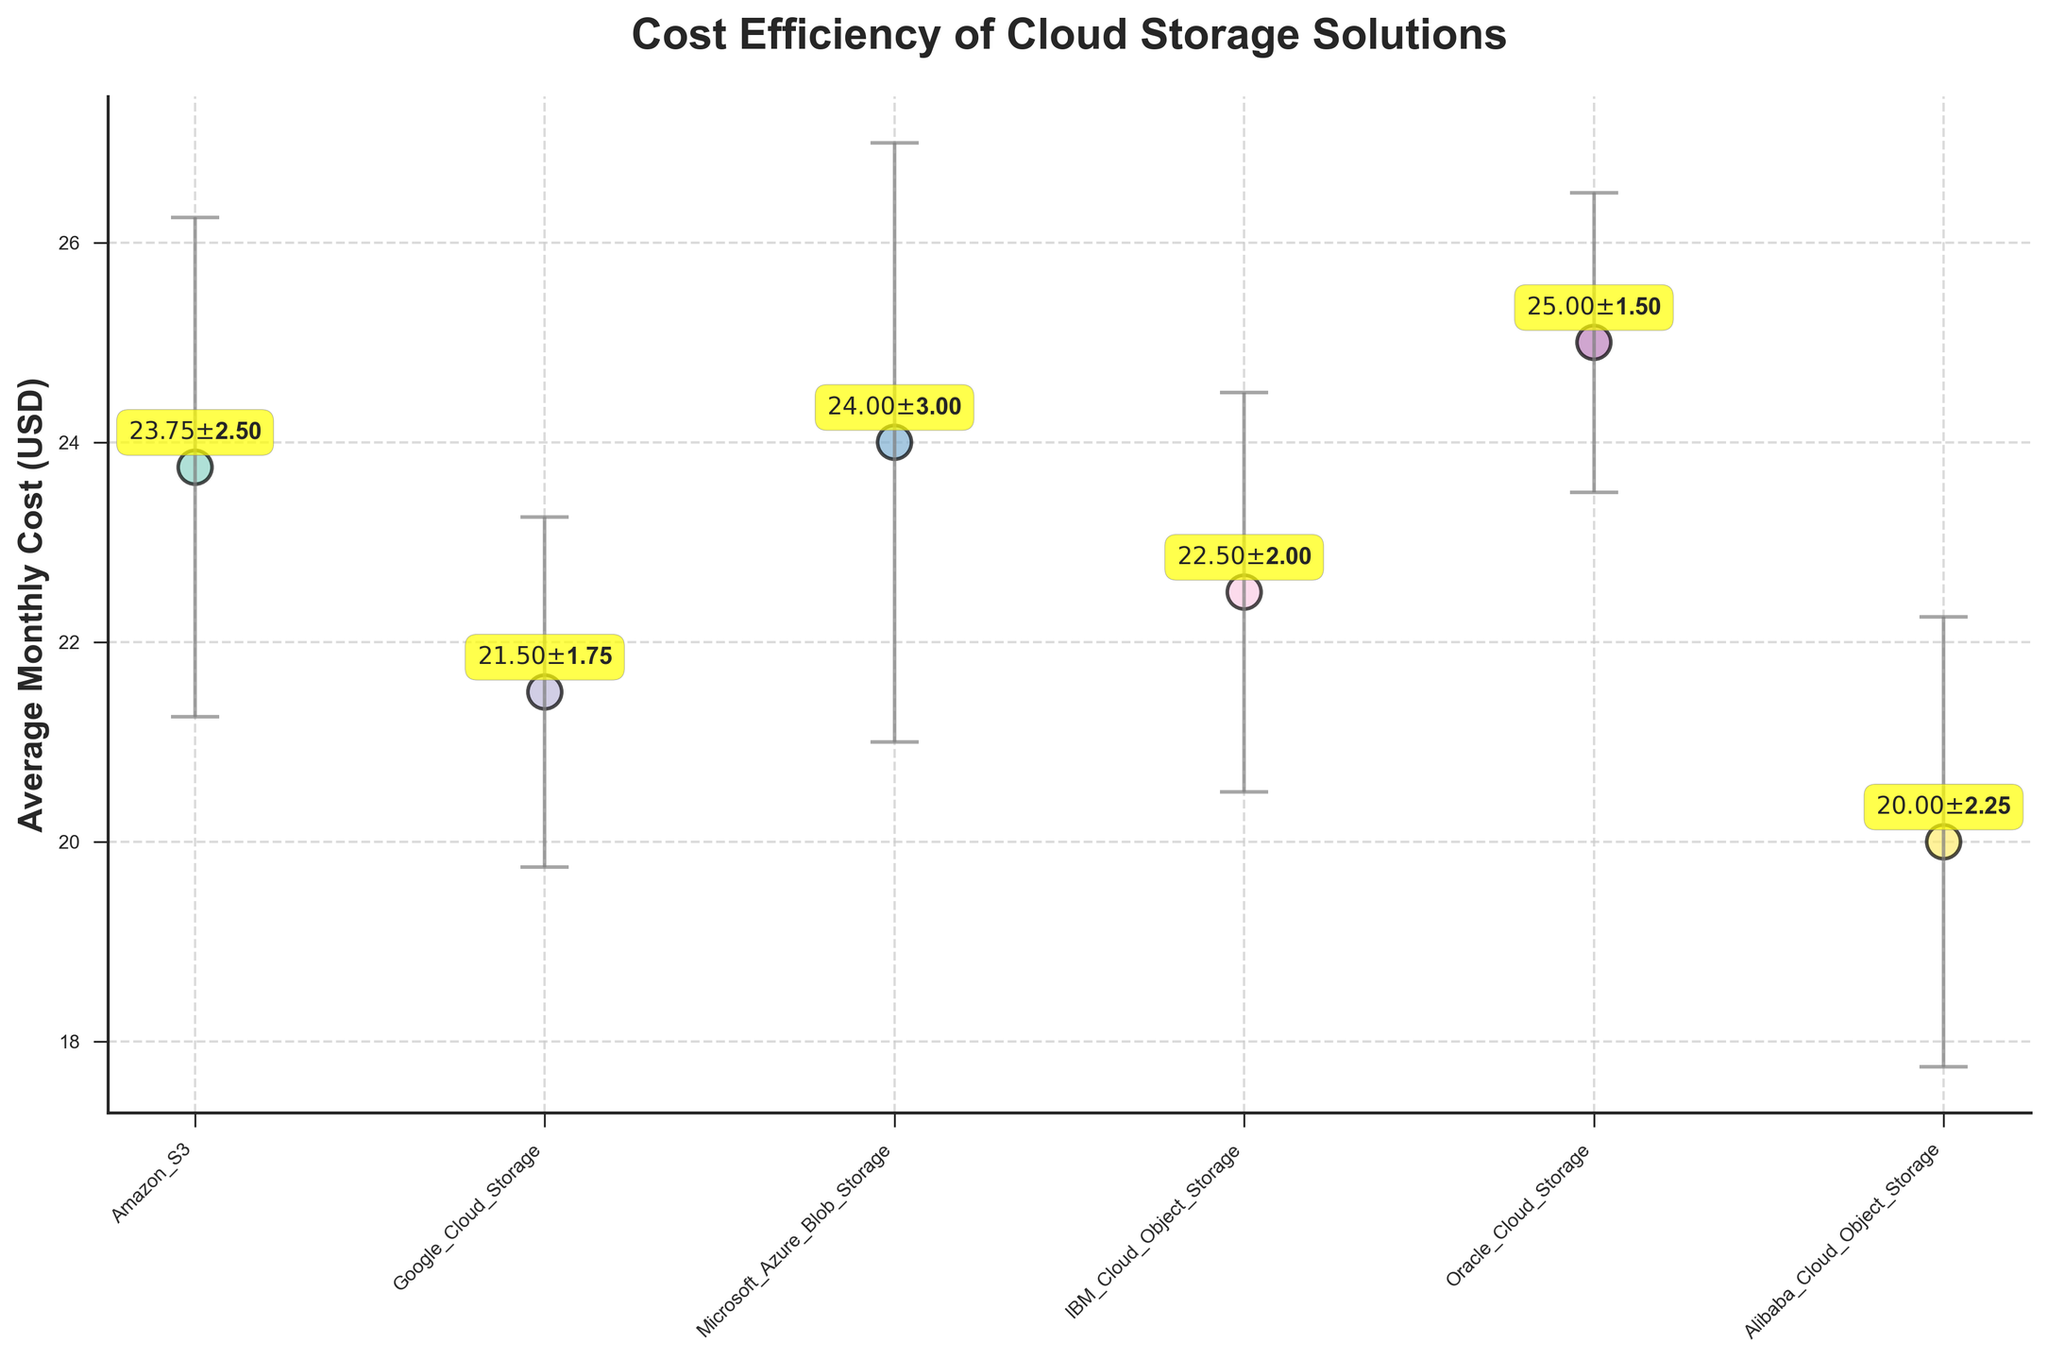What is the average monthly cost for Amazon S3? The figure shows that the average monthly cost for Amazon S3 is indicated next to its data point.
Answer: $23.75 Which cloud storage solution has the highest average monthly cost? By looking at the data points on the scatter plot, Oracle Cloud Storage has the highest average monthly cost.
Answer: Oracle Cloud Storage What is the cost fluctuation for Microsoft Azure Blob Storage? The cost fluctuation for each storage solution is depicted by the error bars in the figure. For Microsoft Azure Blob Storage, it is highlighted next to the data point.
Answer: $3.00 How does the cost of Alibaba Cloud Object Storage compare to Google Cloud Storage? By comparing the positions of the data points on the y-axis, Alibaba Cloud Object Storage has a lower average monthly cost than Google Cloud Storage.
Answer: Lower Which cloud storage solution has the smallest fluctuation in pricing? The smallest error bar corresponds to Oracle Cloud Storage, indicating the least fluctuation in pricing.
Answer: Oracle Cloud Storage What is the range of Amazon S3's cost accounting for its fluctuation? The range is calculated by adding and subtracting the fluctuation from the average monthly cost. For Amazon S3, this is $23.75 ± $2.50, yielding a range of $21.25 to $26.25.
Answer: $21.25 to $26.25 Arrange the cloud storage solutions in ascending order based on average monthly cost. By observing the positions of all data points on the y-axis and noting their respective costs, the ascending order is: Alibaba Cloud Object Storage, Google Cloud Storage, IBM Cloud Object Storage, Amazon S3, Microsoft Azure Blob Storage, Oracle Cloud Storage.
Answer: Alibaba Cloud Object Storage, Google Cloud Storage, IBM Cloud Object Storage, Amazon S3, Microsoft Azure Blob Storage, Oracle Cloud Storage What is the difference in average monthly cost between IBM Cloud and Oracle Cloud Storage? IBM Cloud Object Storage has an average monthly cost of $22.50, and Oracle Cloud Storage has an average monthly cost of $25.00. The difference is $25.00 - $22.50 = $2.50.
Answer: $2.50 Which cloud storage provider's cost fluctuates more, Amazon S3 or Google Cloud Storage? By comparing the lengths of the error bars, Amazon S3 has a larger fluctuation ($2.50) compared to Google Cloud Storage ($1.75).
Answer: Amazon S3 What is the hallmark characteristic of a scatter plot with error bars in this context? The hallmark characteristic in this context is the representation of average monthly costs as points, with error bars indicating the fluctuation in those costs. Each provider's cost and fluctuation are illustrated clearly by these visual elements.
Answer: Representation of costs and fluctuations 